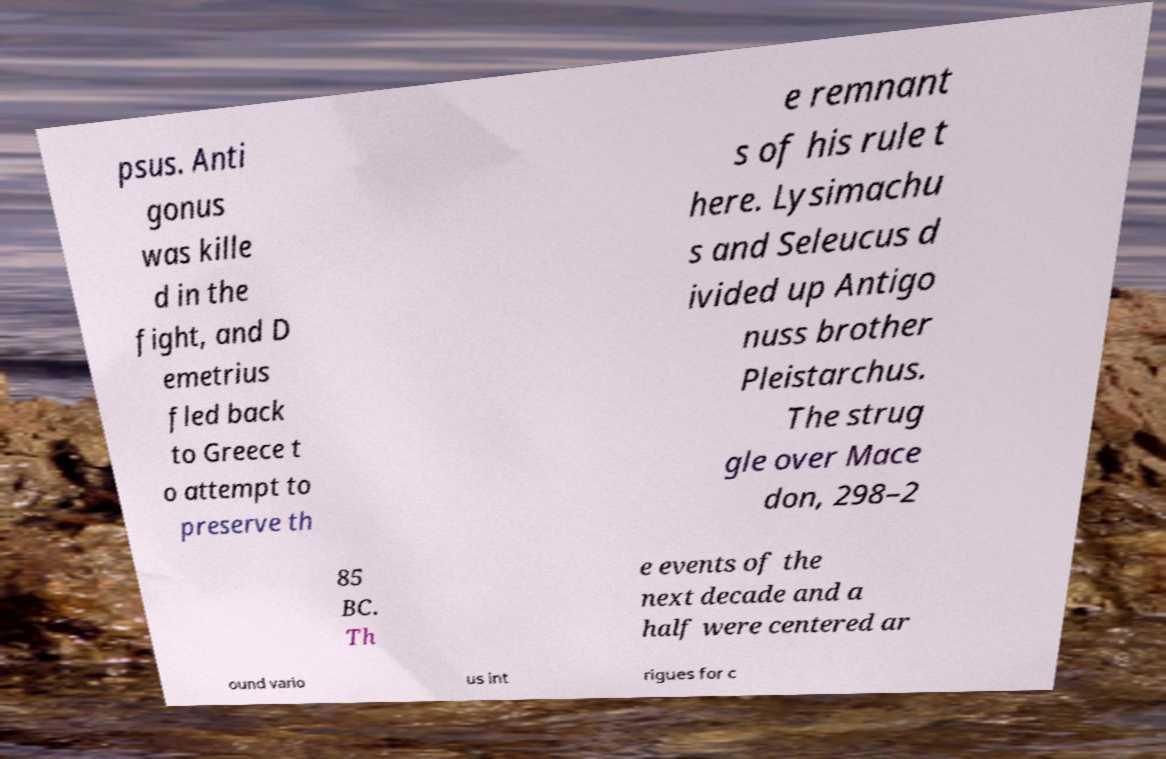Could you extract and type out the text from this image? psus. Anti gonus was kille d in the fight, and D emetrius fled back to Greece t o attempt to preserve th e remnant s of his rule t here. Lysimachu s and Seleucus d ivided up Antigo nuss brother Pleistarchus. The strug gle over Mace don, 298–2 85 BC. Th e events of the next decade and a half were centered ar ound vario us int rigues for c 